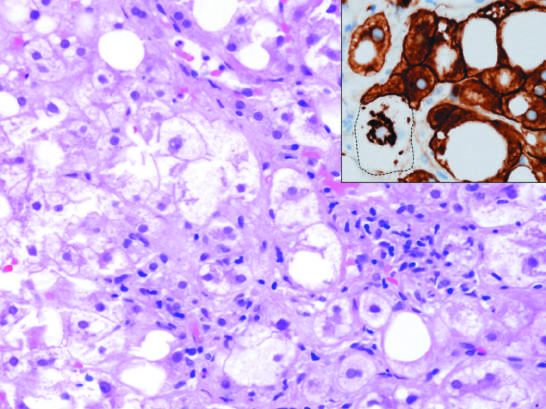what is associated with chronic alcohol use?
Answer the question using a single word or phrase. Hepatoctye injury in fatty liver disease 